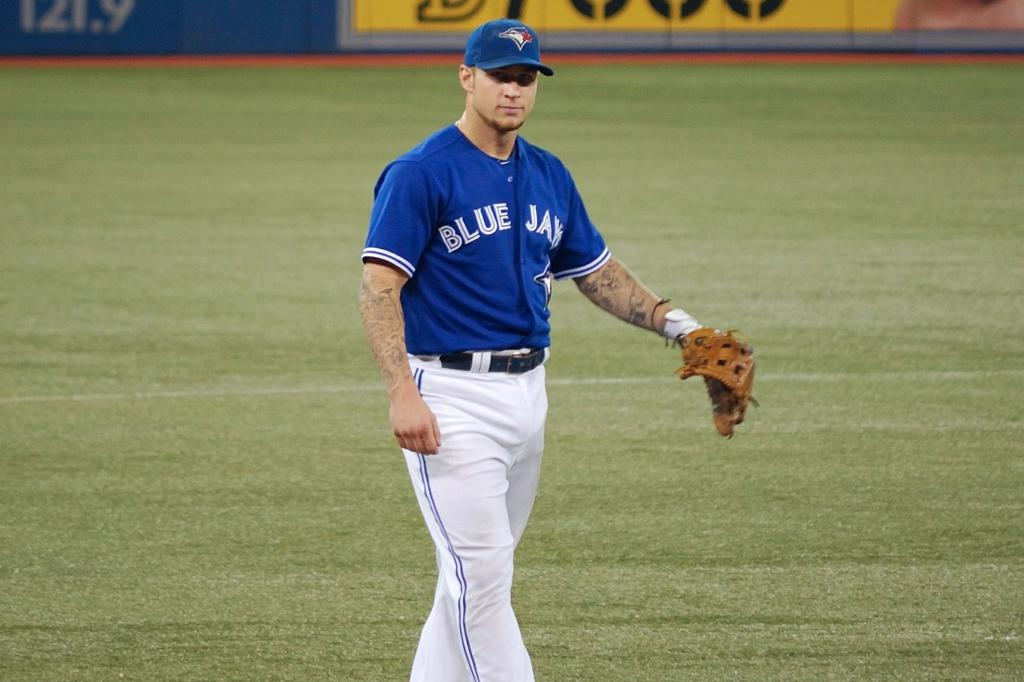<image>
Write a terse but informative summary of the picture. The baseball player with the blue jersey plays for the Bluejays. 